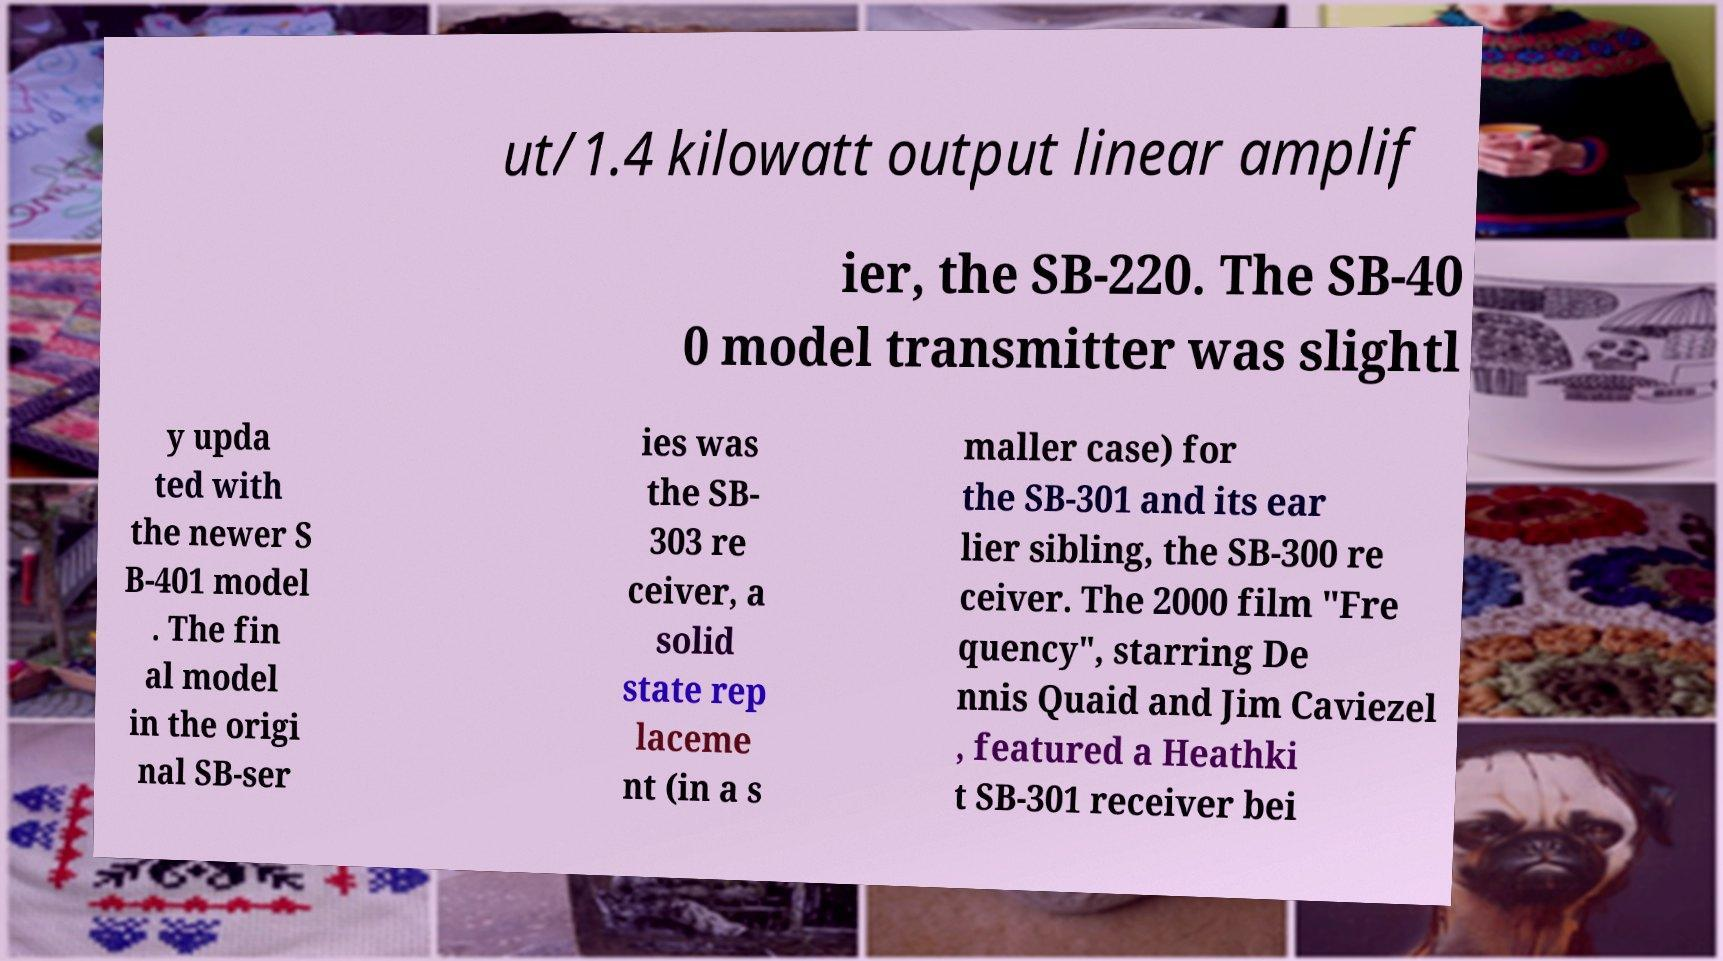Could you extract and type out the text from this image? ut/1.4 kilowatt output linear amplif ier, the SB-220. The SB-40 0 model transmitter was slightl y upda ted with the newer S B-401 model . The fin al model in the origi nal SB-ser ies was the SB- 303 re ceiver, a solid state rep laceme nt (in a s maller case) for the SB-301 and its ear lier sibling, the SB-300 re ceiver. The 2000 film "Fre quency", starring De nnis Quaid and Jim Caviezel , featured a Heathki t SB-301 receiver bei 